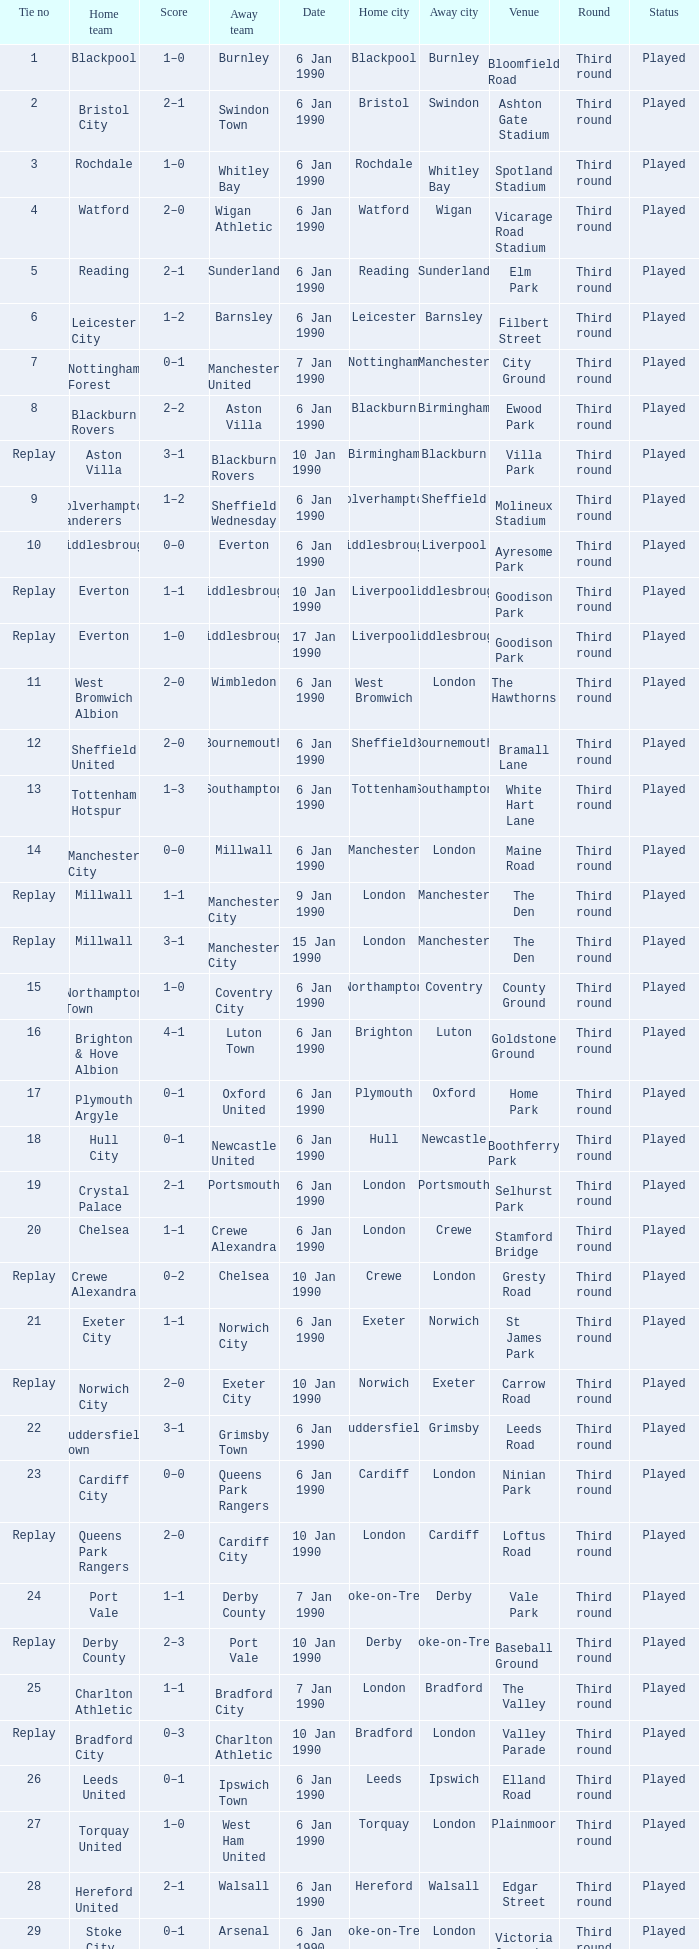What is the tie no of the game where exeter city was the home team? 21.0. 